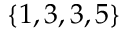Convert formula to latex. <formula><loc_0><loc_0><loc_500><loc_500>\{ 1 , 3 , 3 , 5 \}</formula> 